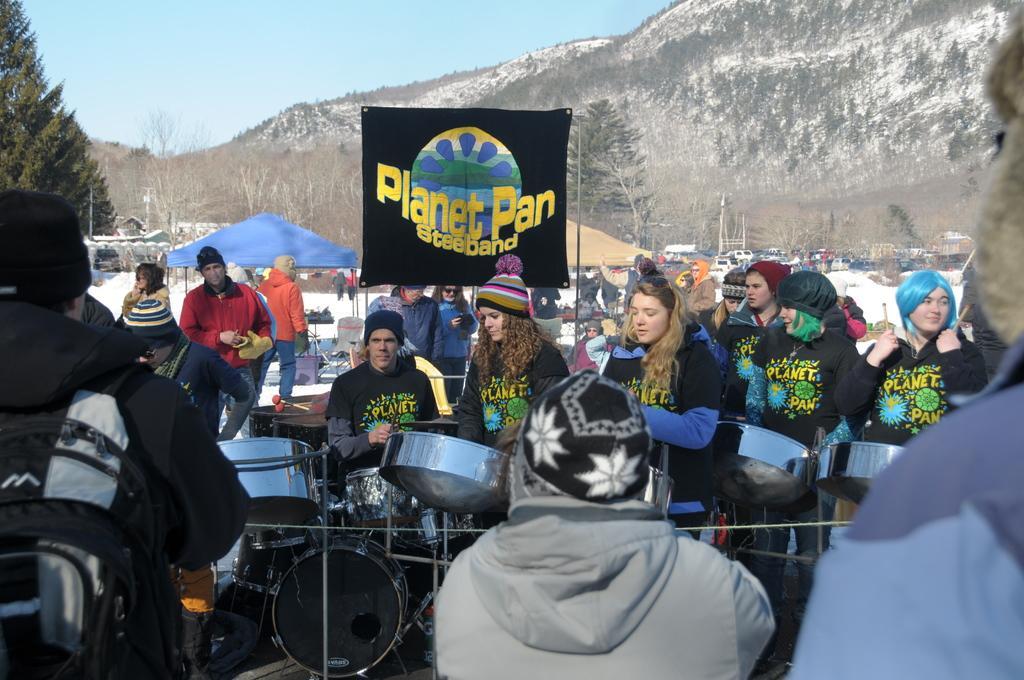Describe this image in one or two sentences. In this image i can see few persons some are standing and some are sitting, at the back ground i can see a banner, a tree, mountain, sky. 